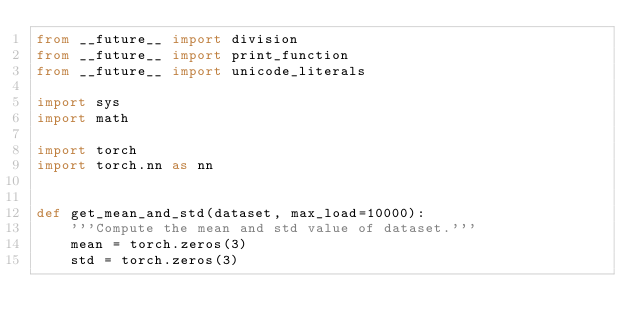<code> <loc_0><loc_0><loc_500><loc_500><_Python_>from __future__ import division
from __future__ import print_function
from __future__ import unicode_literals

import sys
import math

import torch
import torch.nn as nn


def get_mean_and_std(dataset, max_load=10000):
    '''Compute the mean and std value of dataset.'''
    mean = torch.zeros(3)
    std = torch.zeros(3)</code> 